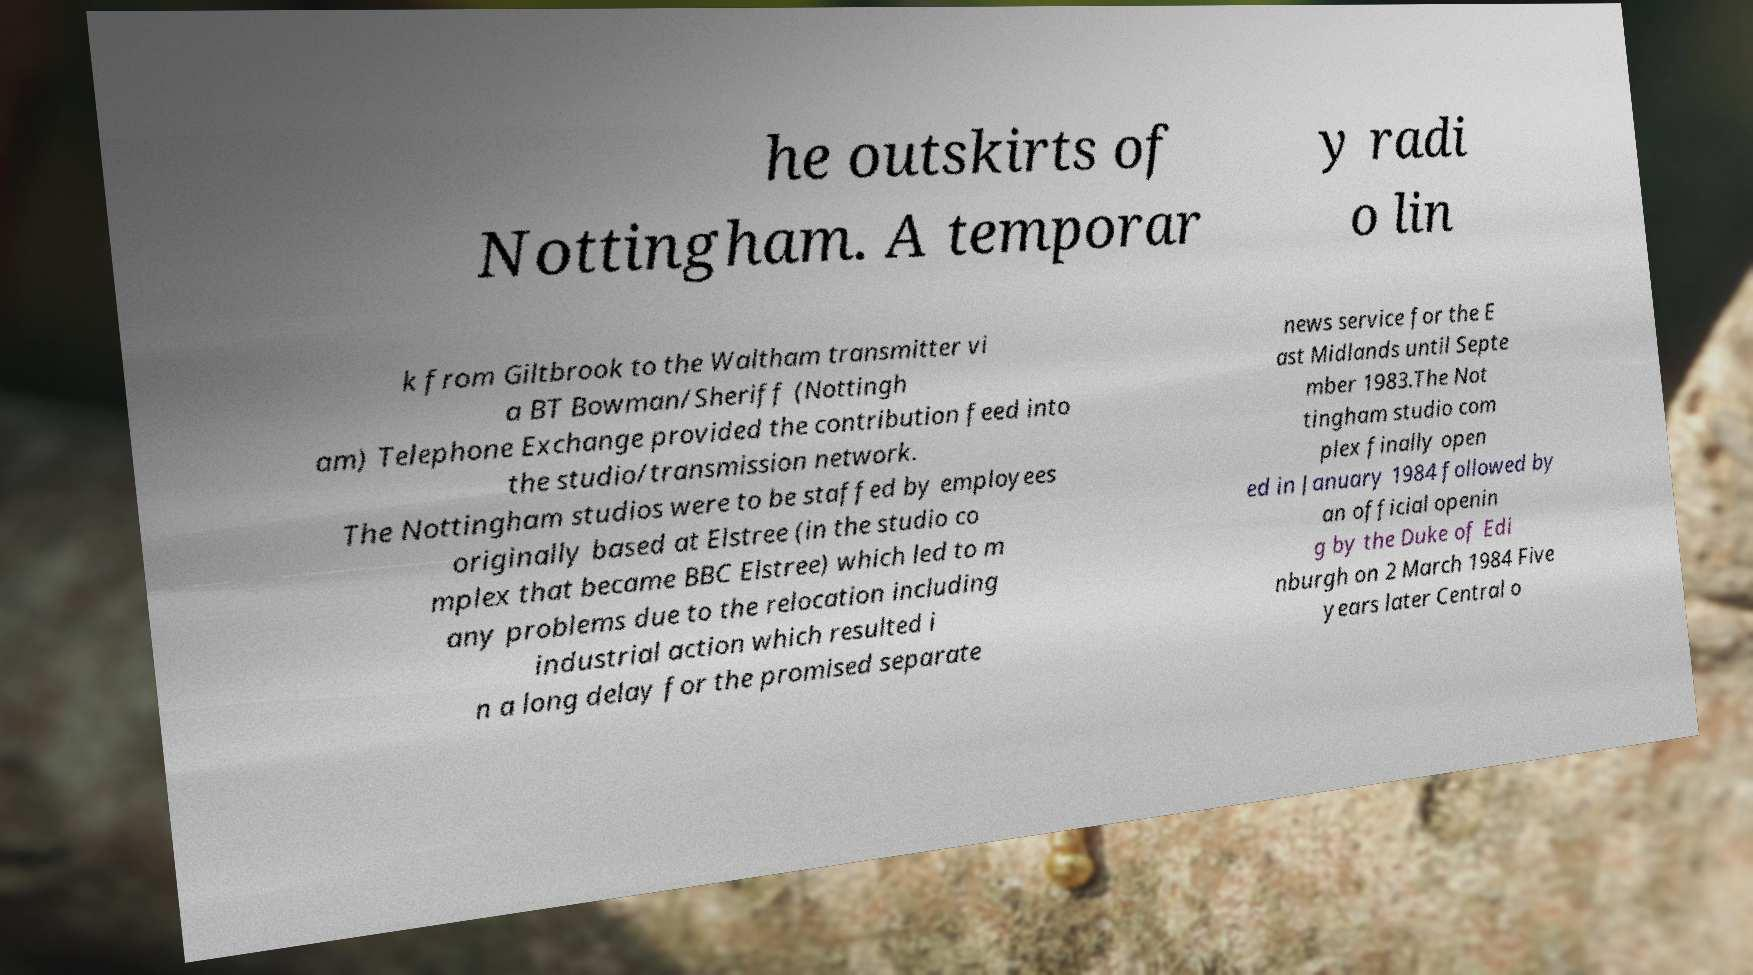Can you read and provide the text displayed in the image?This photo seems to have some interesting text. Can you extract and type it out for me? he outskirts of Nottingham. A temporar y radi o lin k from Giltbrook to the Waltham transmitter vi a BT Bowman/Sheriff (Nottingh am) Telephone Exchange provided the contribution feed into the studio/transmission network. The Nottingham studios were to be staffed by employees originally based at Elstree (in the studio co mplex that became BBC Elstree) which led to m any problems due to the relocation including industrial action which resulted i n a long delay for the promised separate news service for the E ast Midlands until Septe mber 1983.The Not tingham studio com plex finally open ed in January 1984 followed by an official openin g by the Duke of Edi nburgh on 2 March 1984 Five years later Central o 